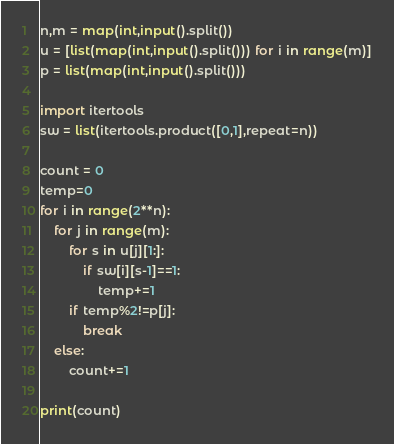<code> <loc_0><loc_0><loc_500><loc_500><_Python_>n,m = map(int,input().split())
u = [list(map(int,input().split())) for i in range(m)]
p = list(map(int,input().split()))

import itertools
sw = list(itertools.product([0,1],repeat=n))

count = 0
temp=0
for i in range(2**n):
    for j in range(m):
        for s in u[j][1:]:
            if sw[i][s-1]==1:
                temp+=1
        if temp%2!=p[j]:
            break
    else:
        count+=1

print(count)</code> 